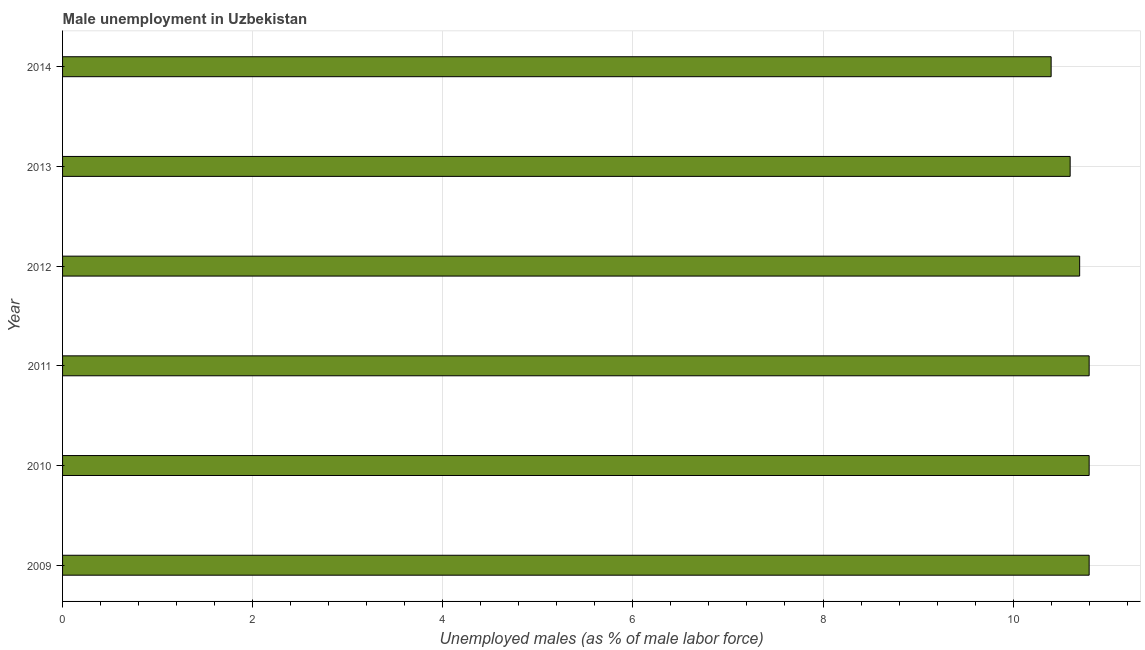Does the graph contain grids?
Give a very brief answer. Yes. What is the title of the graph?
Provide a short and direct response. Male unemployment in Uzbekistan. What is the label or title of the X-axis?
Provide a succinct answer. Unemployed males (as % of male labor force). What is the unemployed males population in 2009?
Make the answer very short. 10.8. Across all years, what is the maximum unemployed males population?
Your response must be concise. 10.8. Across all years, what is the minimum unemployed males population?
Provide a short and direct response. 10.4. In which year was the unemployed males population maximum?
Ensure brevity in your answer.  2009. What is the sum of the unemployed males population?
Offer a terse response. 64.1. What is the average unemployed males population per year?
Your answer should be very brief. 10.68. What is the median unemployed males population?
Your response must be concise. 10.75. Do a majority of the years between 2011 and 2013 (inclusive) have unemployed males population greater than 9.6 %?
Your answer should be compact. Yes. Is the difference between the unemployed males population in 2009 and 2012 greater than the difference between any two years?
Your response must be concise. No. What is the difference between the highest and the second highest unemployed males population?
Your answer should be very brief. 0. What is the difference between the highest and the lowest unemployed males population?
Ensure brevity in your answer.  0.4. In how many years, is the unemployed males population greater than the average unemployed males population taken over all years?
Ensure brevity in your answer.  4. How many bars are there?
Give a very brief answer. 6. What is the difference between two consecutive major ticks on the X-axis?
Your answer should be compact. 2. Are the values on the major ticks of X-axis written in scientific E-notation?
Offer a very short reply. No. What is the Unemployed males (as % of male labor force) in 2009?
Your response must be concise. 10.8. What is the Unemployed males (as % of male labor force) of 2010?
Ensure brevity in your answer.  10.8. What is the Unemployed males (as % of male labor force) in 2011?
Provide a succinct answer. 10.8. What is the Unemployed males (as % of male labor force) in 2012?
Make the answer very short. 10.7. What is the Unemployed males (as % of male labor force) in 2013?
Give a very brief answer. 10.6. What is the Unemployed males (as % of male labor force) of 2014?
Your answer should be compact. 10.4. What is the difference between the Unemployed males (as % of male labor force) in 2009 and 2010?
Your answer should be compact. 0. What is the difference between the Unemployed males (as % of male labor force) in 2009 and 2012?
Give a very brief answer. 0.1. What is the difference between the Unemployed males (as % of male labor force) in 2009 and 2014?
Your response must be concise. 0.4. What is the difference between the Unemployed males (as % of male labor force) in 2010 and 2014?
Provide a short and direct response. 0.4. What is the difference between the Unemployed males (as % of male labor force) in 2011 and 2014?
Offer a very short reply. 0.4. What is the difference between the Unemployed males (as % of male labor force) in 2012 and 2014?
Your answer should be very brief. 0.3. What is the ratio of the Unemployed males (as % of male labor force) in 2009 to that in 2012?
Offer a very short reply. 1.01. What is the ratio of the Unemployed males (as % of male labor force) in 2009 to that in 2013?
Offer a very short reply. 1.02. What is the ratio of the Unemployed males (as % of male labor force) in 2009 to that in 2014?
Offer a terse response. 1.04. What is the ratio of the Unemployed males (as % of male labor force) in 2010 to that in 2012?
Provide a succinct answer. 1.01. What is the ratio of the Unemployed males (as % of male labor force) in 2010 to that in 2013?
Make the answer very short. 1.02. What is the ratio of the Unemployed males (as % of male labor force) in 2010 to that in 2014?
Your response must be concise. 1.04. What is the ratio of the Unemployed males (as % of male labor force) in 2011 to that in 2012?
Keep it short and to the point. 1.01. What is the ratio of the Unemployed males (as % of male labor force) in 2011 to that in 2014?
Offer a terse response. 1.04. What is the ratio of the Unemployed males (as % of male labor force) in 2012 to that in 2013?
Give a very brief answer. 1.01. What is the ratio of the Unemployed males (as % of male labor force) in 2013 to that in 2014?
Give a very brief answer. 1.02. 